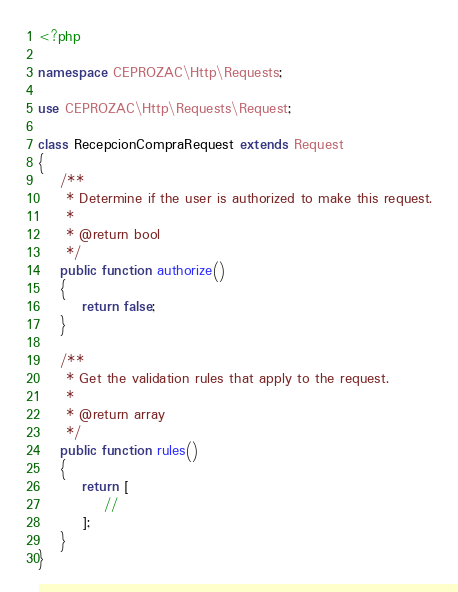<code> <loc_0><loc_0><loc_500><loc_500><_PHP_><?php

namespace CEPROZAC\Http\Requests;

use CEPROZAC\Http\Requests\Request;

class RecepcionCompraRequest extends Request
{
    /**
     * Determine if the user is authorized to make this request.
     *
     * @return bool
     */
    public function authorize()
    {
        return false;
    }

    /**
     * Get the validation rules that apply to the request.
     *
     * @return array
     */
    public function rules()
    {
        return [
            //
        ];
    }
}
</code> 